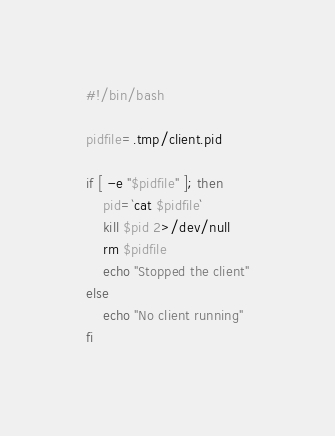Convert code to text. <code><loc_0><loc_0><loc_500><loc_500><_Bash_>#!/bin/bash

pidfile=.tmp/client.pid

if [ -e "$pidfile" ]; then
    pid=`cat $pidfile`
    kill $pid 2>/dev/null
    rm $pidfile
    echo "Stopped the client"
else
    echo "No client running"
fi
</code> 